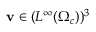<formula> <loc_0><loc_0><loc_500><loc_500>v \in ( L ^ { \infty } ( \Omega _ { c } ) ) ^ { 3 }</formula> 